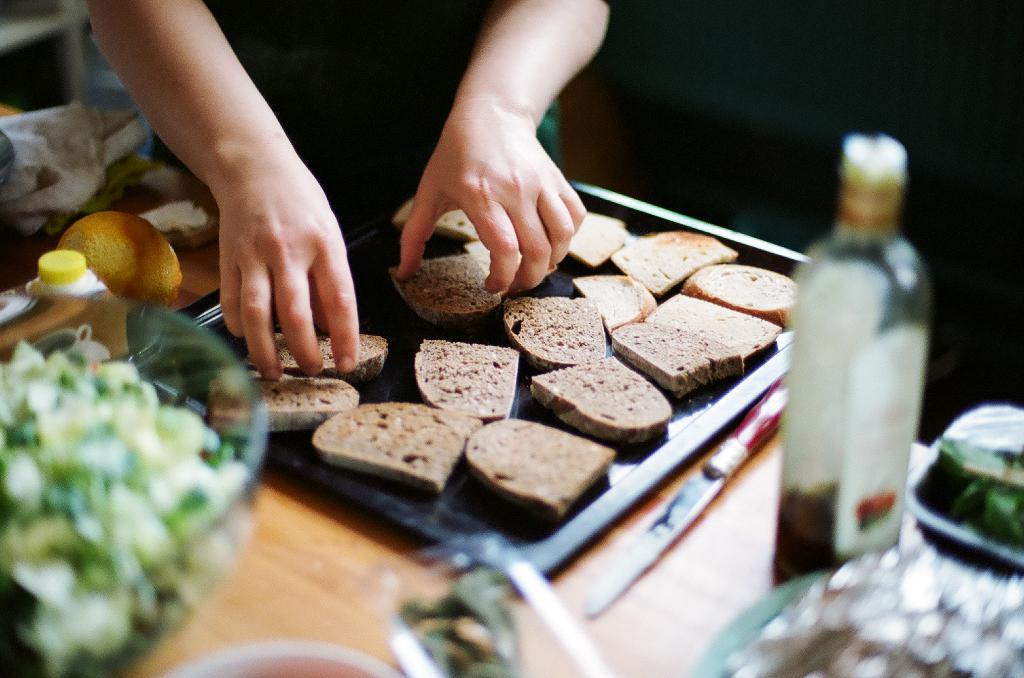What is happening in the image involving the person? The person's hands are taking pieces of bread from a black tray. What objects are present on the table in the image? There is a knife, a bottle, a bowl of salad, and fruits on the table. What might the person be using the knife for? The knife could be used for cutting the bread or other food items on the table. What type of food is in the bowl on the table? The bowl on the table contains a salad. How many ducks are swimming in the bowl of salad in the image? There are no ducks present in the image, and the bowl of salad does not contain any ducks. 